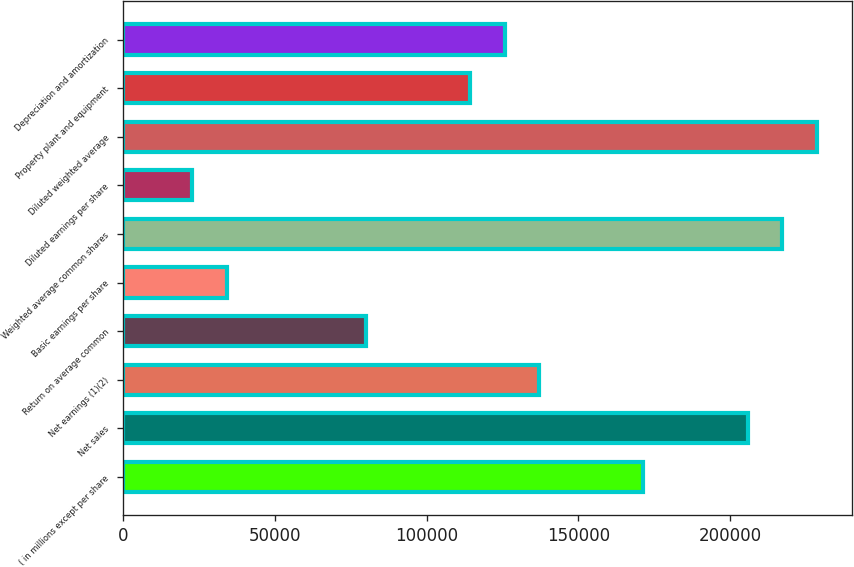Convert chart. <chart><loc_0><loc_0><loc_500><loc_500><bar_chart><fcel>( in millions except per share<fcel>Net sales<fcel>Net earnings (1)(2)<fcel>Return on average common<fcel>Basic earnings per share<fcel>Weighted average common shares<fcel>Diluted earnings per share<fcel>Diluted weighted average<fcel>Property plant and equipment<fcel>Depreciation and amortization<nl><fcel>171412<fcel>205695<fcel>137130<fcel>79992.6<fcel>34282.7<fcel>217122<fcel>22855.2<fcel>228550<fcel>114275<fcel>125703<nl></chart> 